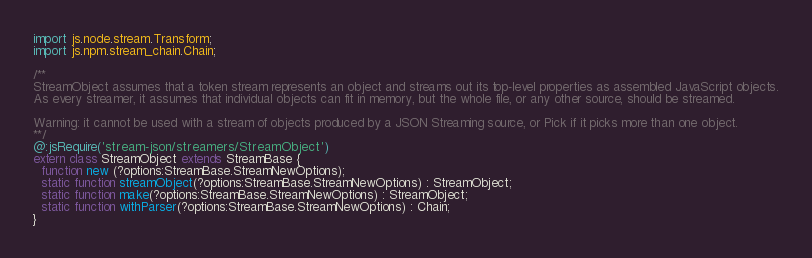Convert code to text. <code><loc_0><loc_0><loc_500><loc_500><_Haxe_>import js.node.stream.Transform;
import js.npm.stream_chain.Chain;

/**
StreamObject assumes that a token stream represents an object and streams out its top-level properties as assembled JavaScript objects.
As every streamer, it assumes that individual objects can fit in memory, but the whole file, or any other source, should be streamed.

Warning: it cannot be used with a stream of objects produced by a JSON Streaming source, or Pick if it picks more than one object.
**/
@:jsRequire('stream-json/streamers/StreamObject')
extern class StreamObject extends StreamBase {
  function new (?options:StreamBase.StreamNewOptions);
  static function streamObject(?options:StreamBase.StreamNewOptions) : StreamObject;
  static function make(?options:StreamBase.StreamNewOptions) : StreamObject;
  static function withParser(?options:StreamBase.StreamNewOptions) : Chain;
}</code> 